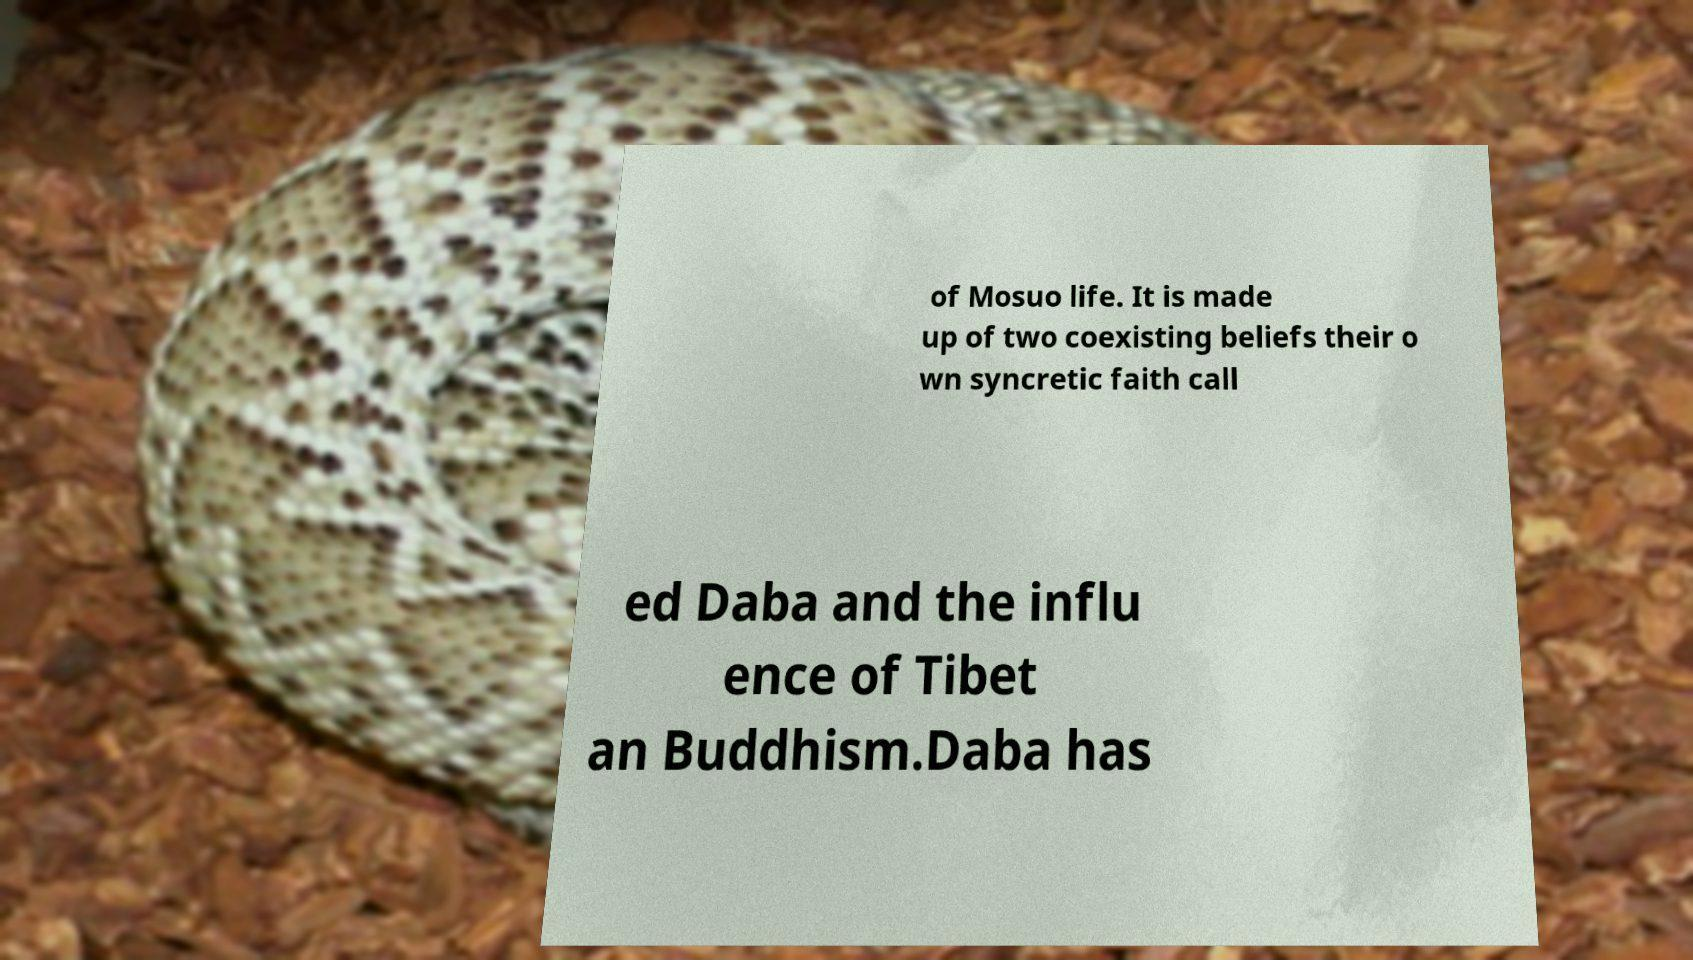Please identify and transcribe the text found in this image. of Mosuo life. It is made up of two coexisting beliefs their o wn syncretic faith call ed Daba and the influ ence of Tibet an Buddhism.Daba has 